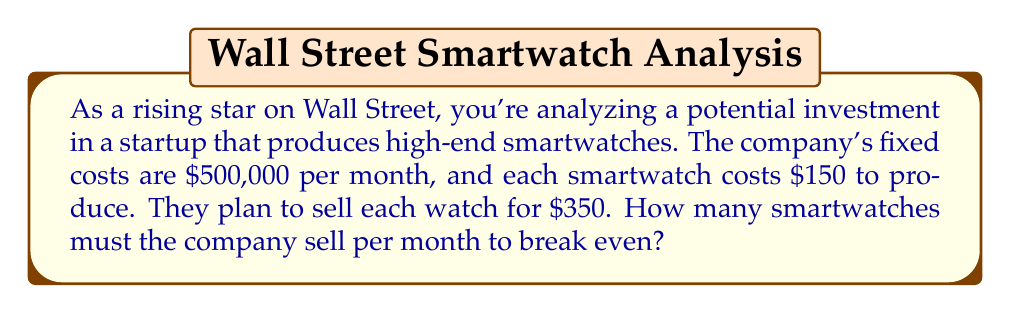Provide a solution to this math problem. To solve this problem, we'll use the break-even formula:

$$ \text{Break-even point} = \frac{\text{Fixed Costs}}{\text{Price per unit} - \text{Variable Cost per unit}} $$

Let's define our variables:
- Fixed Costs (FC) = $500,000
- Price per unit (P) = $350
- Variable Cost per unit (VC) = $150

Now, let's plug these values into our formula:

$$ \text{Break-even point} = \frac{500,000}{350 - 150} $$

$$ = \frac{500,000}{200} $$

$$ = 2,500 $$

To verify this result, we can use the total revenue and total cost equations:

Total Revenue: $R = 350x$
Total Cost: $C = 500,000 + 150x$

At the break-even point, these should be equal:

$$ 350x = 500,000 + 150x $$

Solving for x:

$$ 200x = 500,000 $$
$$ x = 2,500 $$

This confirms our initial calculation.
Answer: The company must sell 2,500 smartwatches per month to break even. 